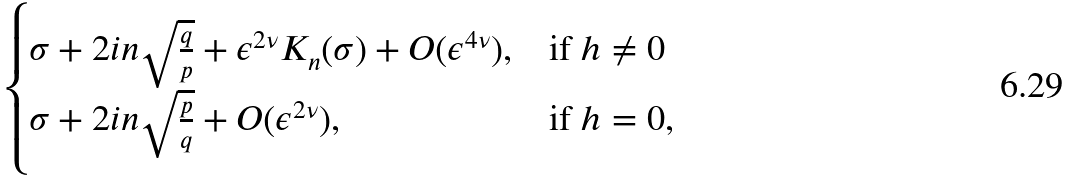Convert formula to latex. <formula><loc_0><loc_0><loc_500><loc_500>\begin{cases} \sigma + 2 i n \sqrt { \frac { q } { p } } + \epsilon ^ { 2 \nu } K _ { n } ( \sigma ) + O ( \epsilon ^ { 4 \nu } ) , & \text {if $h \neq 0$} \\ \sigma + 2 i n \sqrt { \frac { p } { q } } + O ( \epsilon ^ { 2 \nu } ) , & \text {if $h = 0$} , \\ \end{cases}</formula> 